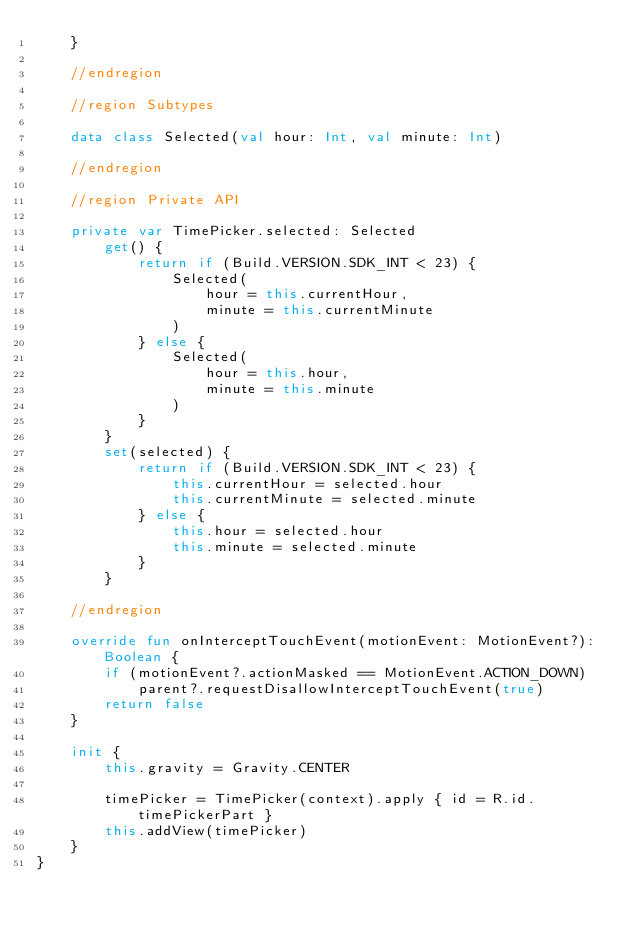Convert code to text. <code><loc_0><loc_0><loc_500><loc_500><_Kotlin_>    }

    //endregion

    //region Subtypes

    data class Selected(val hour: Int, val minute: Int)

    //endregion

    //region Private API

    private var TimePicker.selected: Selected
        get() {
            return if (Build.VERSION.SDK_INT < 23) {
                Selected(
                    hour = this.currentHour,
                    minute = this.currentMinute
                )
            } else {
                Selected(
                    hour = this.hour,
                    minute = this.minute
                )
            }
        }
        set(selected) {
            return if (Build.VERSION.SDK_INT < 23) {
                this.currentHour = selected.hour
                this.currentMinute = selected.minute
            } else {
                this.hour = selected.hour
                this.minute = selected.minute
            }
        }

    //endregion

    override fun onInterceptTouchEvent(motionEvent: MotionEvent?): Boolean {
        if (motionEvent?.actionMasked == MotionEvent.ACTION_DOWN)
            parent?.requestDisallowInterceptTouchEvent(true)
        return false
    }

    init {
        this.gravity = Gravity.CENTER

        timePicker = TimePicker(context).apply { id = R.id.timePickerPart }
        this.addView(timePicker)
    }
}
</code> 